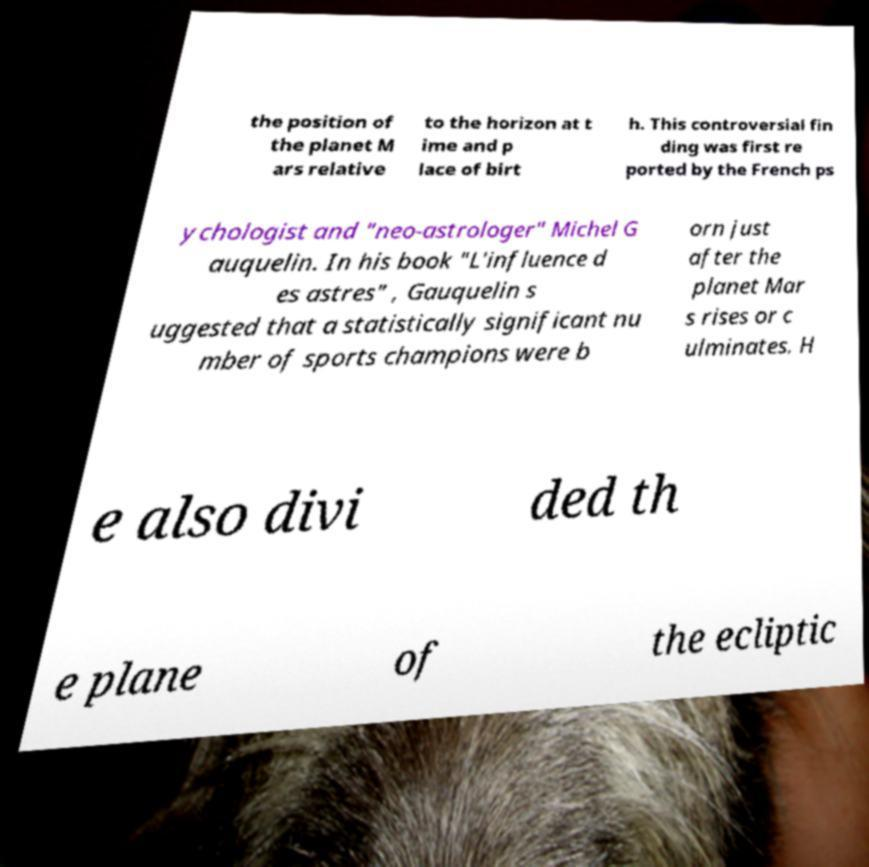There's text embedded in this image that I need extracted. Can you transcribe it verbatim? the position of the planet M ars relative to the horizon at t ime and p lace of birt h. This controversial fin ding was first re ported by the French ps ychologist and "neo-astrologer" Michel G auquelin. In his book "L'influence d es astres" , Gauquelin s uggested that a statistically significant nu mber of sports champions were b orn just after the planet Mar s rises or c ulminates. H e also divi ded th e plane of the ecliptic 